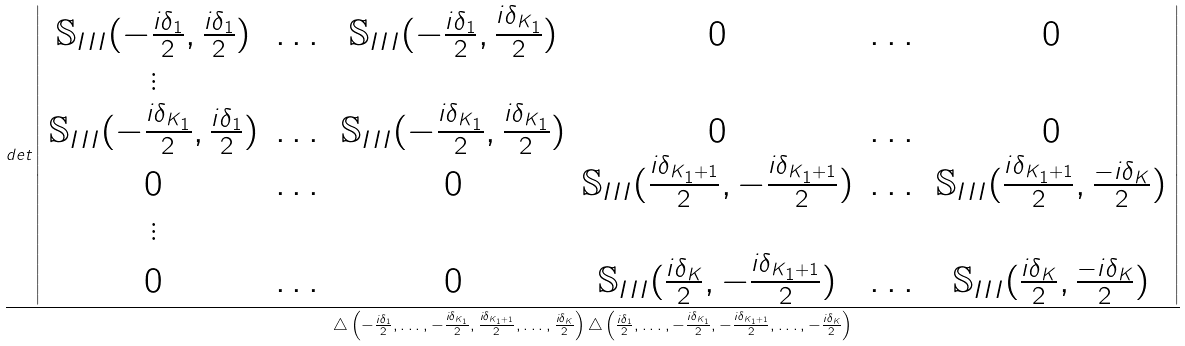Convert formula to latex. <formula><loc_0><loc_0><loc_500><loc_500>\frac { d e t \left | \begin{array} { c c c c c c } \mathbb { S } _ { I I I } ( - \frac { i \delta _ { 1 } } { 2 } , \frac { i \delta _ { 1 } } { 2 } ) & \dots & \mathbb { S } _ { I I I } ( - \frac { i \delta _ { 1 } } { 2 } , \frac { i \delta _ { K _ { 1 } } } { 2 } ) & 0 & \dots & 0 \\ \vdots & & & & & \\ \mathbb { S } _ { I I I } ( - \frac { i \delta _ { K _ { 1 } } } { 2 } , \frac { i \delta _ { 1 } } { 2 } ) & \dots & \mathbb { S } _ { I I I } ( - \frac { i \delta _ { K _ { 1 } } } { 2 } , \frac { i \delta _ { K _ { 1 } } } { 2 } ) & 0 & \dots & 0 \\ 0 & \dots & 0 & \mathbb { S } _ { I I I } ( \frac { i \delta _ { K _ { 1 } + 1 } } { 2 } , - \frac { i \delta _ { K _ { 1 } + 1 } } { 2 } ) & \dots & \mathbb { S } _ { I I I } ( \frac { i \delta _ { K _ { 1 } + 1 } } { 2 } , \frac { - i \delta _ { K } } { 2 } ) \\ \vdots & & & & & \\ 0 & \dots & 0 & \mathbb { S } _ { I I I } ( \frac { i \delta _ { K } } { 2 } , - \frac { i \delta _ { K _ { 1 } + 1 } } { 2 } ) & \dots & \mathbb { S } _ { I I I } ( \frac { i \delta _ { K } } { 2 } , \frac { - i \delta _ { K } } { 2 } ) \end{array} \right | } { \triangle \left ( - \frac { i \delta _ { 1 } } { 2 } , \dots , - \frac { i \delta _ { K _ { 1 } } } { 2 } , \frac { i \delta _ { K _ { 1 } + 1 } } { 2 } , \dots , \frac { i \delta _ { K } } { 2 } \right ) \triangle \left ( \frac { i \delta _ { 1 } } { 2 } , \dots , - \frac { i \delta _ { K _ { 1 } } } { 2 } , - \frac { i \delta _ { K _ { 1 } + 1 } } { 2 } , \dots , - \frac { i \delta _ { K } } { 2 } \right ) }</formula> 